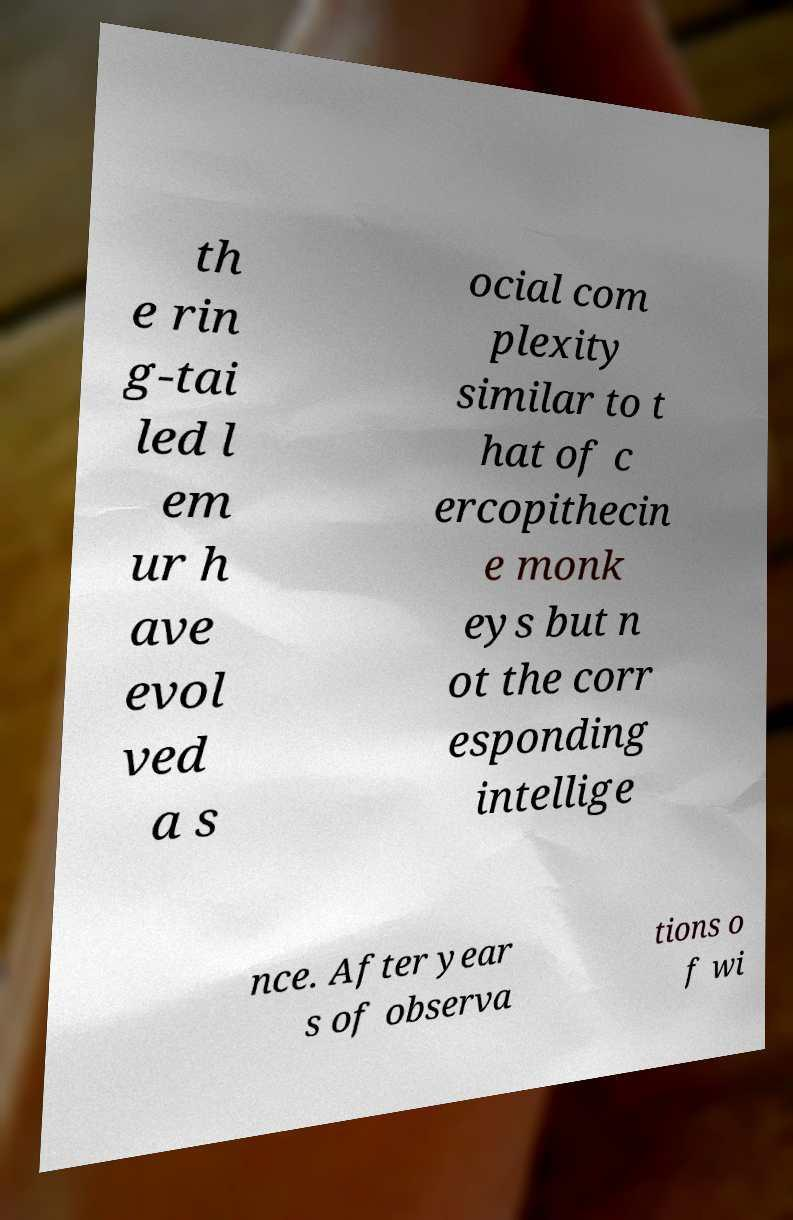For documentation purposes, I need the text within this image transcribed. Could you provide that? th e rin g-tai led l em ur h ave evol ved a s ocial com plexity similar to t hat of c ercopithecin e monk eys but n ot the corr esponding intellige nce. After year s of observa tions o f wi 